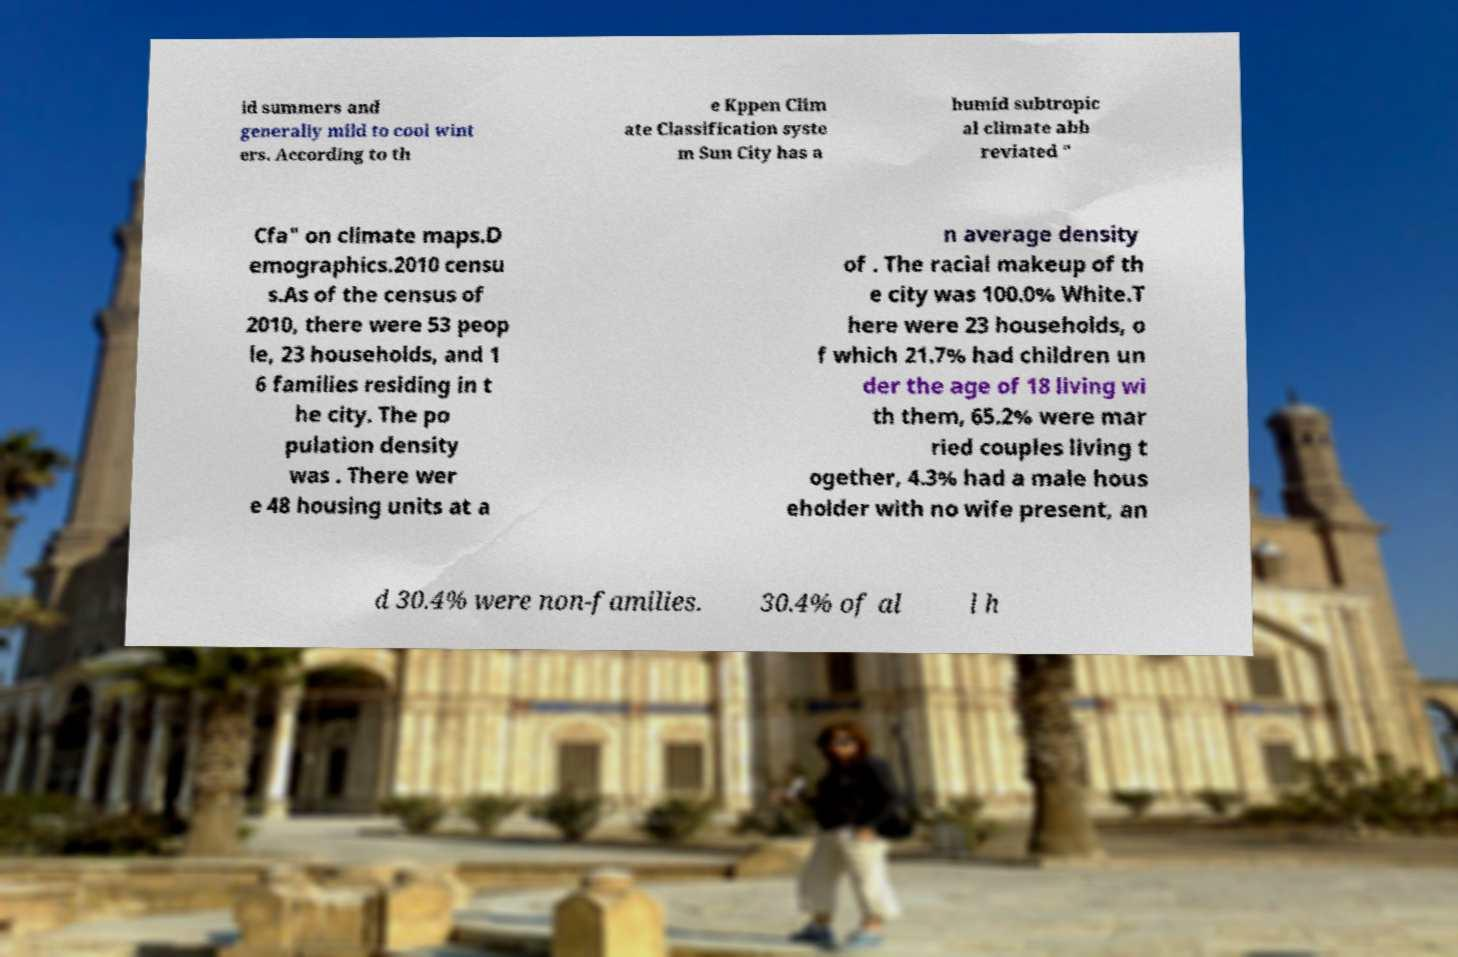Please read and relay the text visible in this image. What does it say? id summers and generally mild to cool wint ers. According to th e Kppen Clim ate Classification syste m Sun City has a humid subtropic al climate abb reviated " Cfa" on climate maps.D emographics.2010 censu s.As of the census of 2010, there were 53 peop le, 23 households, and 1 6 families residing in t he city. The po pulation density was . There wer e 48 housing units at a n average density of . The racial makeup of th e city was 100.0% White.T here were 23 households, o f which 21.7% had children un der the age of 18 living wi th them, 65.2% were mar ried couples living t ogether, 4.3% had a male hous eholder with no wife present, an d 30.4% were non-families. 30.4% of al l h 